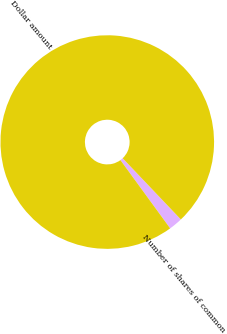<chart> <loc_0><loc_0><loc_500><loc_500><pie_chart><fcel>Number of shares of common<fcel>Dollar amount<nl><fcel>2.08%<fcel>97.92%<nl></chart> 